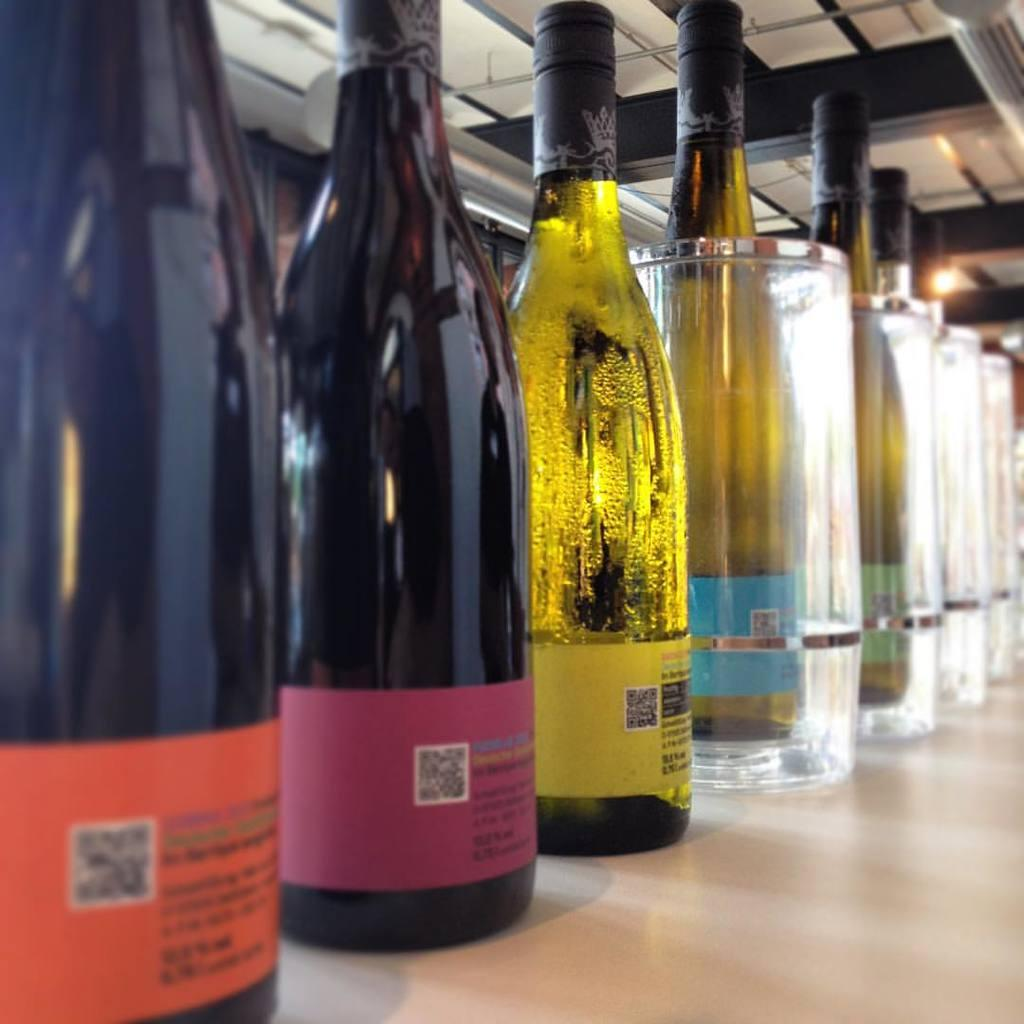What type of items are present on the table in the image? There are many bottles of alcohol on the table in the image. Can you describe the setting where the bottles are located? The bottles are kept on a table, and a roof is visible at the top of the image. What type of chickens can be seen roaming around the bottles of alcohol in the image? There are no chickens present in the image; it only features bottles of alcohol on a table. 